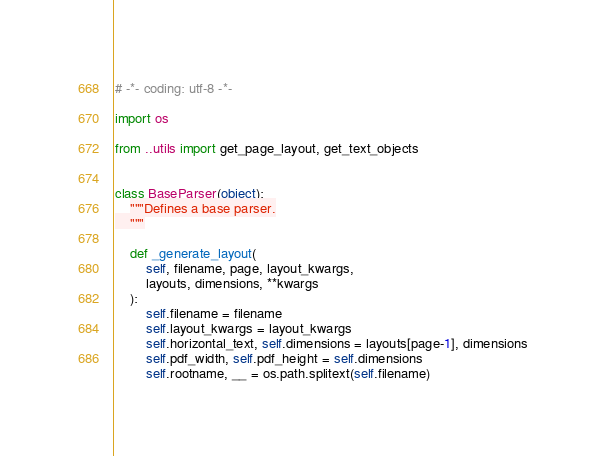<code> <loc_0><loc_0><loc_500><loc_500><_Python_># -*- coding: utf-8 -*-

import os

from ..utils import get_page_layout, get_text_objects


class BaseParser(object):
    """Defines a base parser.
    """

    def _generate_layout(
        self, filename, page, layout_kwargs,
        layouts, dimensions, **kwargs
    ):
        self.filename = filename
        self.layout_kwargs = layout_kwargs
        self.horizontal_text, self.dimensions = layouts[page-1], dimensions
        self.pdf_width, self.pdf_height = self.dimensions
        self.rootname, __ = os.path.splitext(self.filename)
</code> 